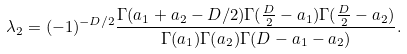<formula> <loc_0><loc_0><loc_500><loc_500>\lambda _ { 2 } = ( - 1 ) ^ { - D / 2 } \frac { \Gamma ( a _ { 1 } + a _ { 2 } - D / 2 ) \Gamma ( \frac { D } { 2 } - a _ { 1 } ) \Gamma ( \frac { D } { 2 } - a _ { 2 } ) } { \Gamma ( a _ { 1 } ) \Gamma ( a _ { 2 } ) \Gamma ( D - a _ { 1 } - a _ { 2 } ) } .</formula> 